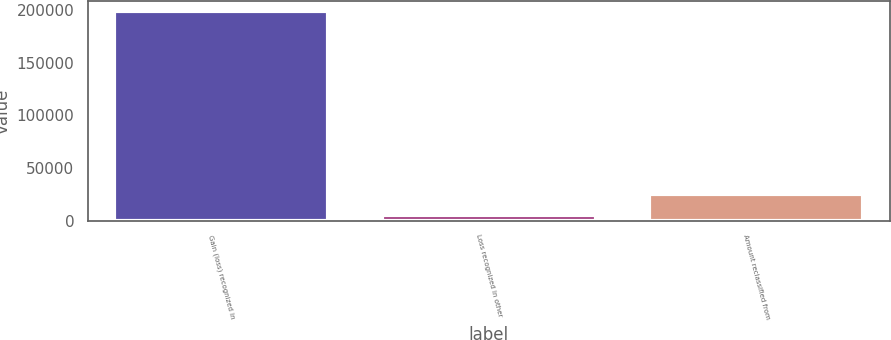Convert chart. <chart><loc_0><loc_0><loc_500><loc_500><bar_chart><fcel>Gain (loss) recognized in<fcel>Loss recognized in other<fcel>Amount reclassified from<nl><fcel>198595<fcel>5753<fcel>25037.2<nl></chart> 